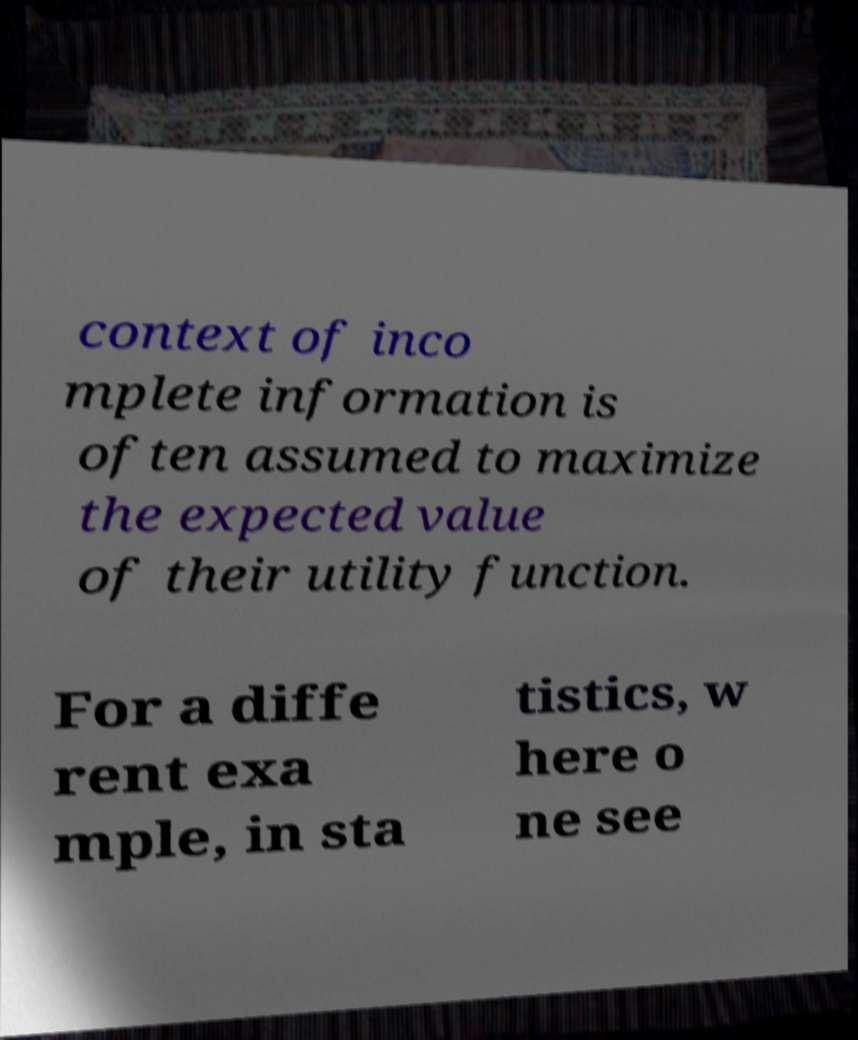Please read and relay the text visible in this image. What does it say? context of inco mplete information is often assumed to maximize the expected value of their utility function. For a diffe rent exa mple, in sta tistics, w here o ne see 